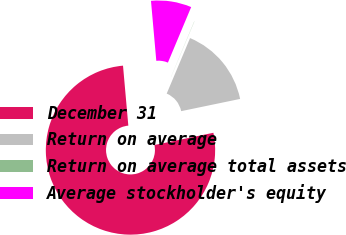Convert chart to OTSL. <chart><loc_0><loc_0><loc_500><loc_500><pie_chart><fcel>December 31<fcel>Return on average<fcel>Return on average total assets<fcel>Average stockholder's equity<nl><fcel>76.85%<fcel>15.4%<fcel>0.03%<fcel>7.72%<nl></chart> 